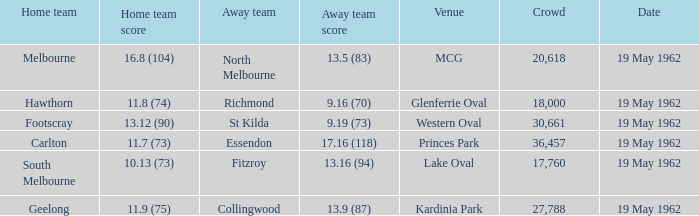What day is the venue the western oval? 19 May 1962. 